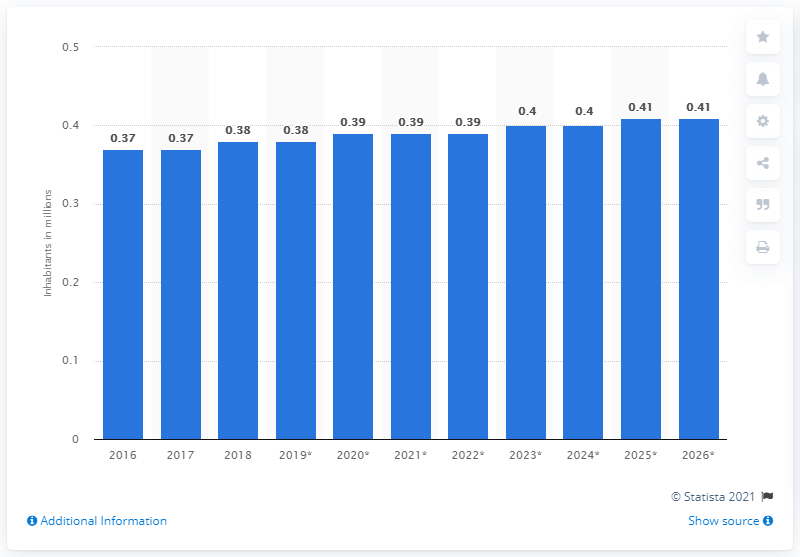Give some essential details in this illustration. In 2018, the Bahamas had a population of 380,000. 